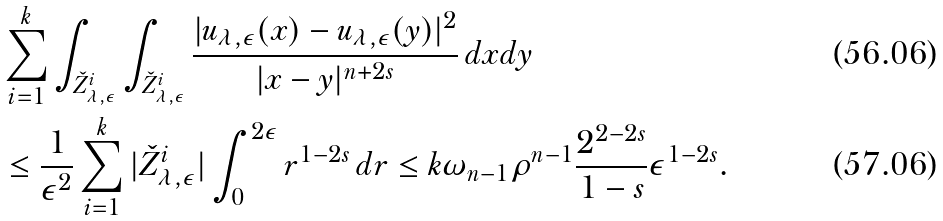Convert formula to latex. <formula><loc_0><loc_0><loc_500><loc_500>& \sum _ { i = 1 } ^ { k } { \int _ { \check { Z } _ { \lambda , \epsilon } ^ { i } } { \int _ { \check { Z } _ { \lambda , \epsilon } ^ { i } } { \frac { | u _ { \lambda , \epsilon } ( x ) - u _ { \lambda , \epsilon } ( y ) | ^ { 2 } } { | x - y | ^ { n + 2 s } } \, d x } d y } } \\ & \leq \frac { 1 } { \epsilon ^ { 2 } } \sum _ { i = 1 } ^ { k } { | \check { Z } _ { \lambda , \epsilon } ^ { i } | \int _ { 0 } ^ { 2 \epsilon } { r ^ { 1 - 2 s } \, d r } } \leq k \omega _ { n - 1 } \rho ^ { n - 1 } \frac { 2 ^ { 2 - 2 s } } { 1 - s } \epsilon ^ { 1 - 2 s } .</formula> 